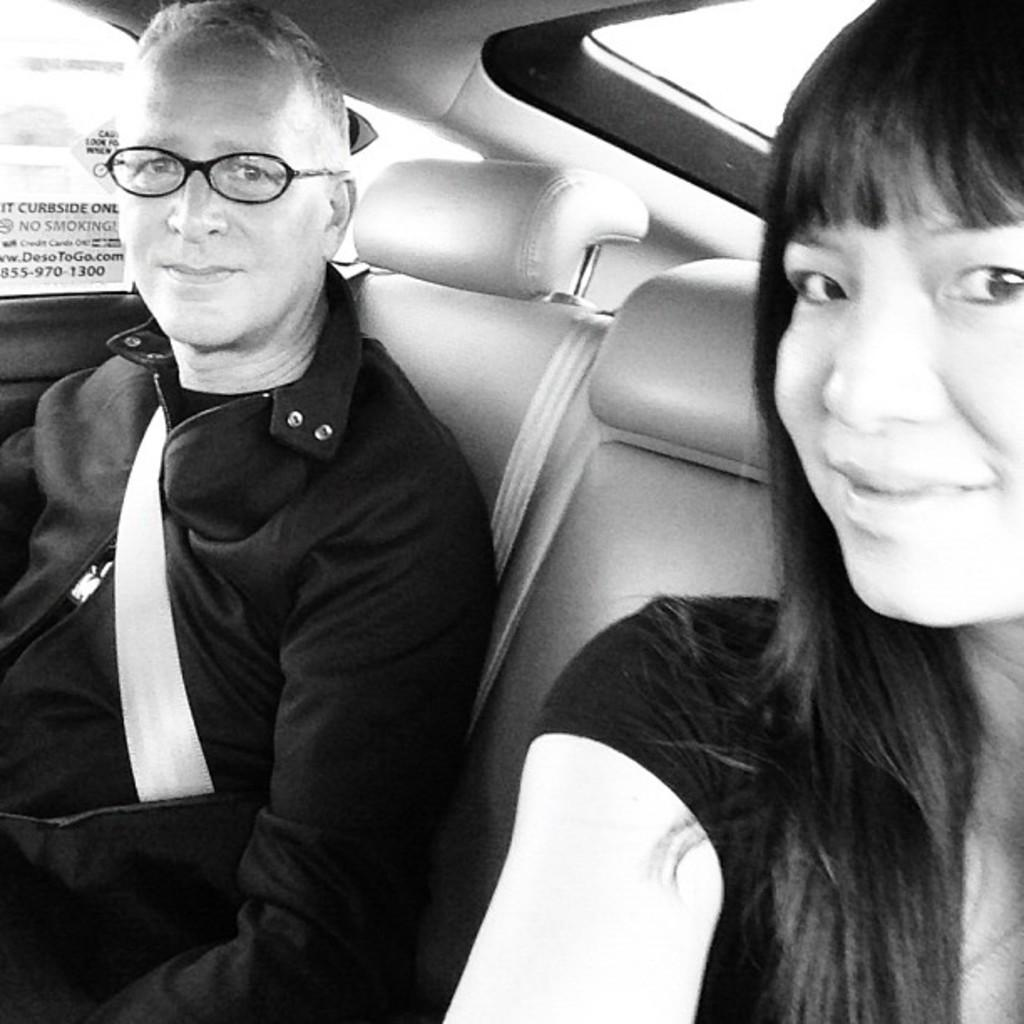How many people are in the image? A: There are two persons in the image. What are the two persons doing in the image? The two persons are sitting in a car. What color are the dresses worn by the persons in the image? Both persons are wearing black dresses. What type of temper does the judge have in the image? There is no judge present in the image, so it is not possible to determine their temper. 